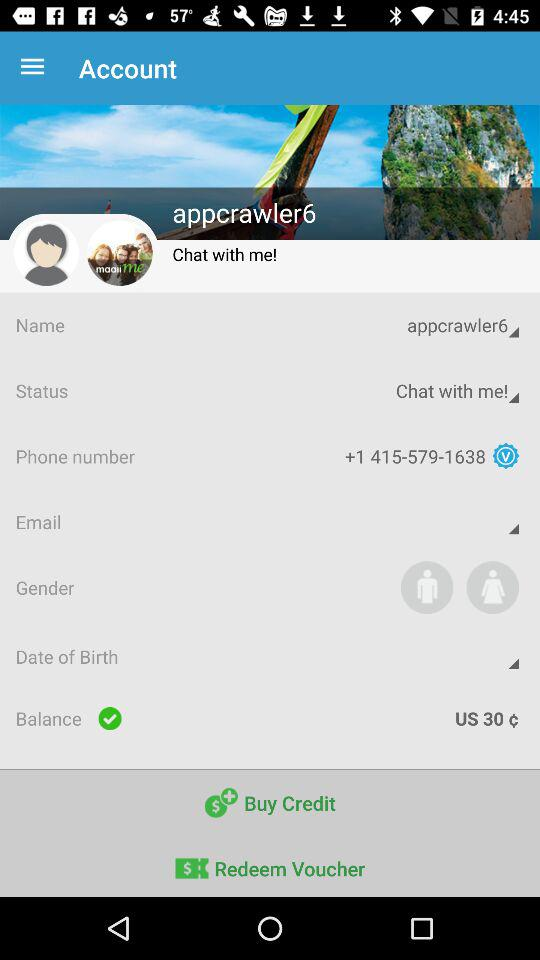What is the username? The username is "appcrawler6". 